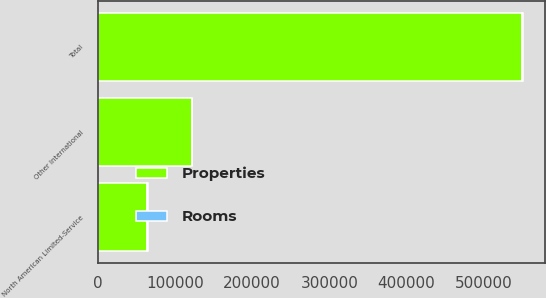Convert chart. <chart><loc_0><loc_0><loc_500><loc_500><stacked_bar_chart><ecel><fcel>North American Limited-Service<fcel>Other International<fcel>Total<nl><fcel>Rooms<fcel>408<fcel>524<fcel>1957<nl><fcel>Properties<fcel>64372<fcel>121508<fcel>549664<nl></chart> 